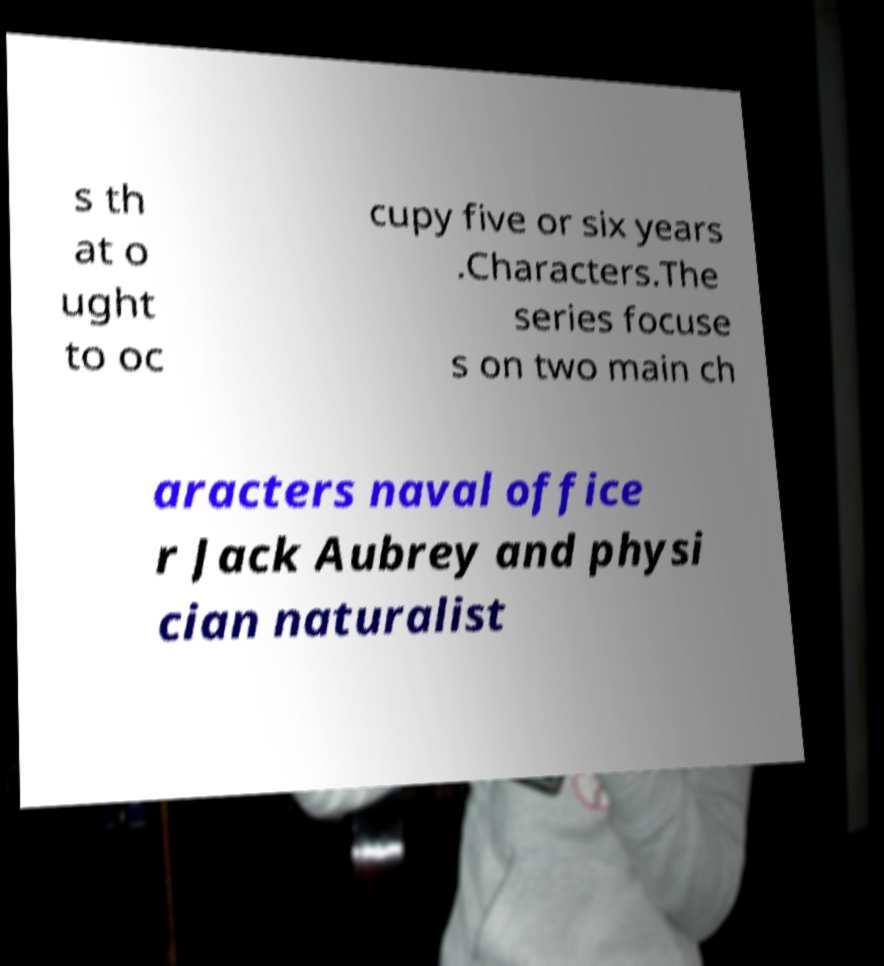Please read and relay the text visible in this image. What does it say? s th at o ught to oc cupy five or six years .Characters.The series focuse s on two main ch aracters naval office r Jack Aubrey and physi cian naturalist 